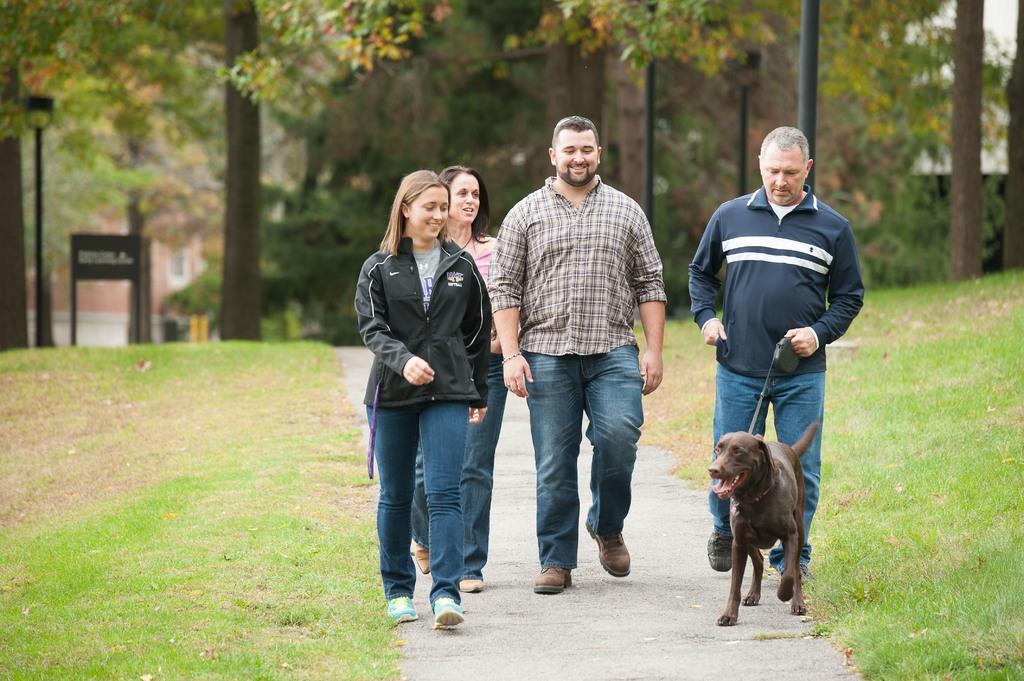How would you summarize this image in a sentence or two? In the picture I can see few persons walking where one among them is holding a belt which is tightened to a dog in front of them and there is greenery ground on either sides of them and there are trees and some other objects in the background. 